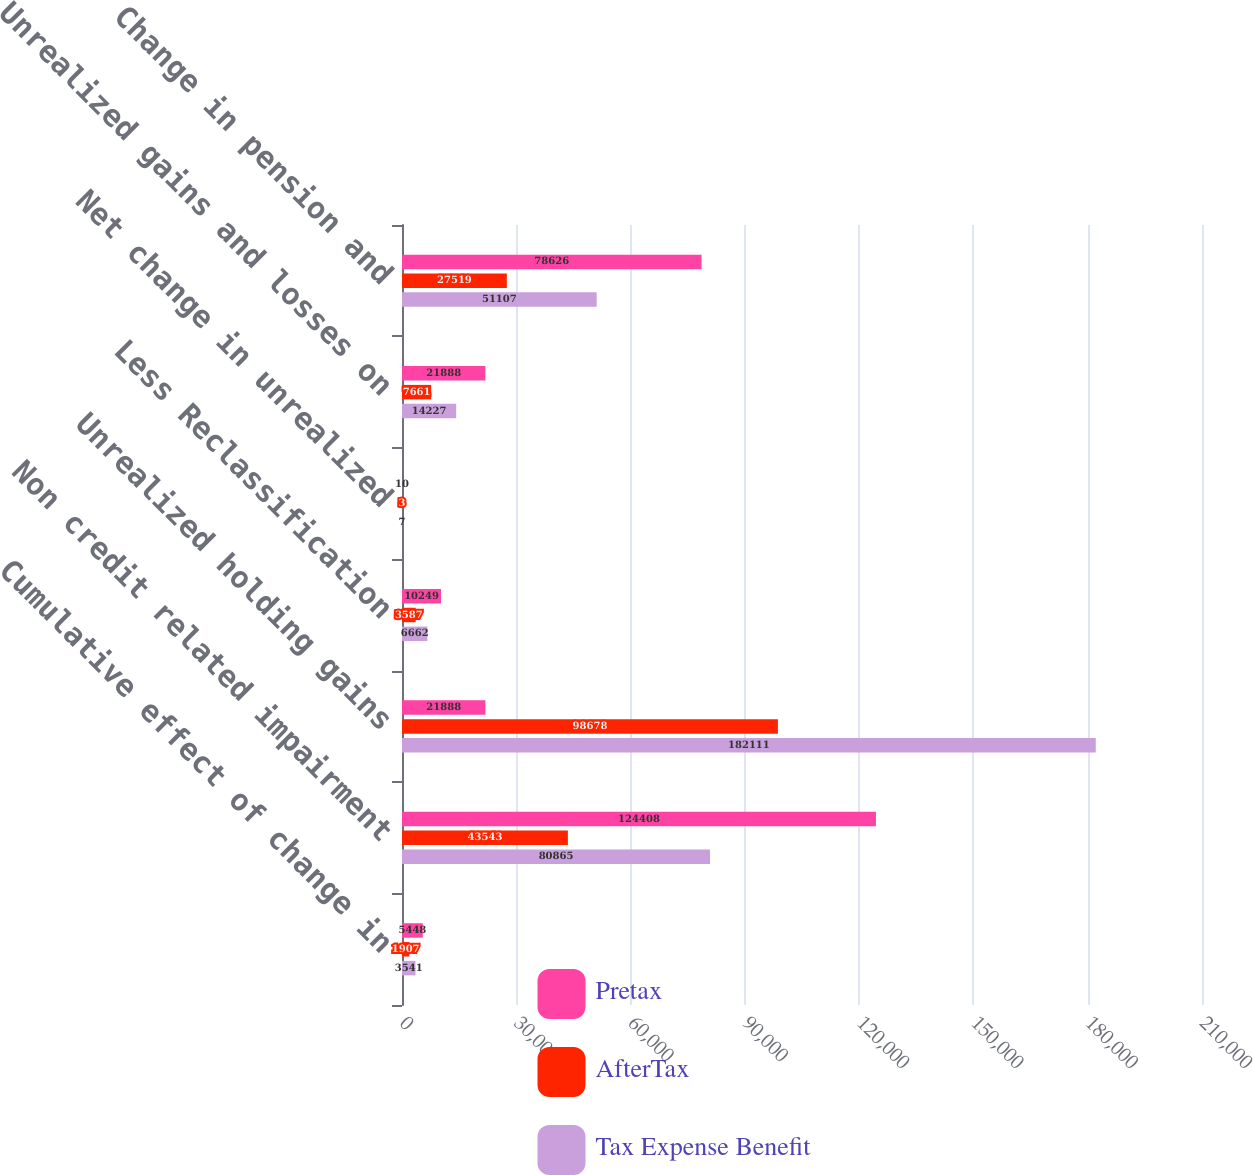Convert chart. <chart><loc_0><loc_0><loc_500><loc_500><stacked_bar_chart><ecel><fcel>Cumulative effect of change in<fcel>Non credit related impairment<fcel>Unrealized holding gains<fcel>Less Reclassification<fcel>Net change in unrealized<fcel>Unrealized gains and losses on<fcel>Change in pension and<nl><fcel>Pretax<fcel>5448<fcel>124408<fcel>21888<fcel>10249<fcel>10<fcel>21888<fcel>78626<nl><fcel>AfterTax<fcel>1907<fcel>43543<fcel>98678<fcel>3587<fcel>3<fcel>7661<fcel>27519<nl><fcel>Tax Expense Benefit<fcel>3541<fcel>80865<fcel>182111<fcel>6662<fcel>7<fcel>14227<fcel>51107<nl></chart> 